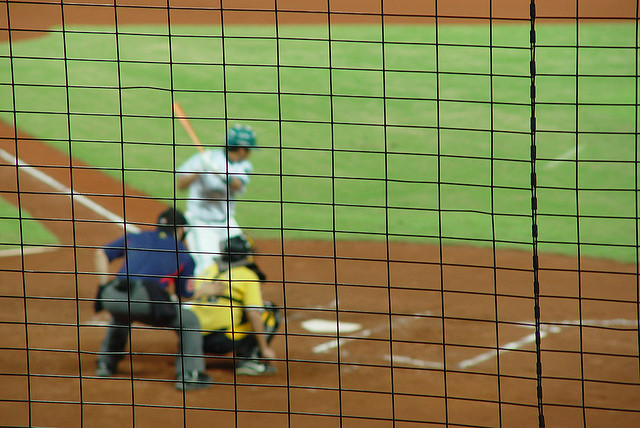<image>What are the names of the teams? I don't know the names of the teams. It could be any combination like 'orioles and braves', 'mets and giants', 'marlins and pirates', 'cubs and bears', 'braves', 'cubs and sox', 'mariners and cubs'. What are the names of the teams? I am not sure the names of the teams. It can be seen 'orioles and braves', 'mets and giants', 'marlins and pirates', 'cubs and bears', 'braves', 'cubs and sox', or 'mariners and cubs'. 